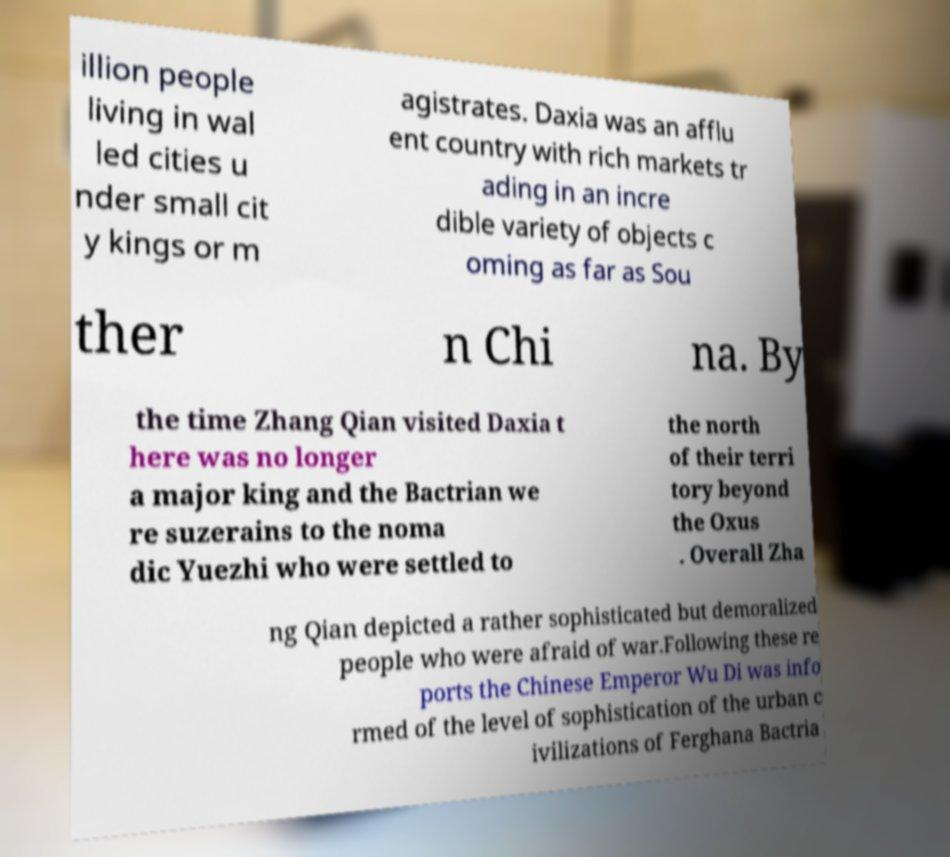Can you read and provide the text displayed in the image?This photo seems to have some interesting text. Can you extract and type it out for me? illion people living in wal led cities u nder small cit y kings or m agistrates. Daxia was an afflu ent country with rich markets tr ading in an incre dible variety of objects c oming as far as Sou ther n Chi na. By the time Zhang Qian visited Daxia t here was no longer a major king and the Bactrian we re suzerains to the noma dic Yuezhi who were settled to the north of their terri tory beyond the Oxus . Overall Zha ng Qian depicted a rather sophisticated but demoralized people who were afraid of war.Following these re ports the Chinese Emperor Wu Di was info rmed of the level of sophistication of the urban c ivilizations of Ferghana Bactria 